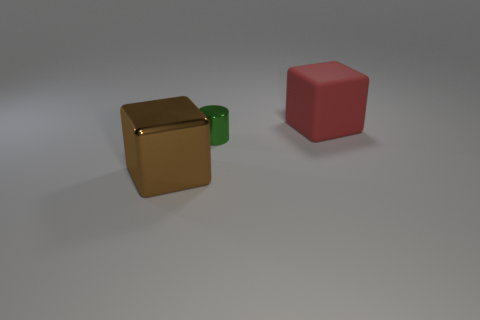Add 2 brown metallic cylinders. How many objects exist? 5 Subtract 1 cubes. How many cubes are left? 1 Subtract all purple spheres. How many brown blocks are left? 1 Subtract all large matte things. Subtract all red rubber things. How many objects are left? 1 Add 1 tiny green shiny things. How many tiny green shiny things are left? 2 Add 2 green objects. How many green objects exist? 3 Subtract all red blocks. How many blocks are left? 1 Subtract 0 red balls. How many objects are left? 3 Subtract all cylinders. How many objects are left? 2 Subtract all red cylinders. Subtract all green balls. How many cylinders are left? 1 